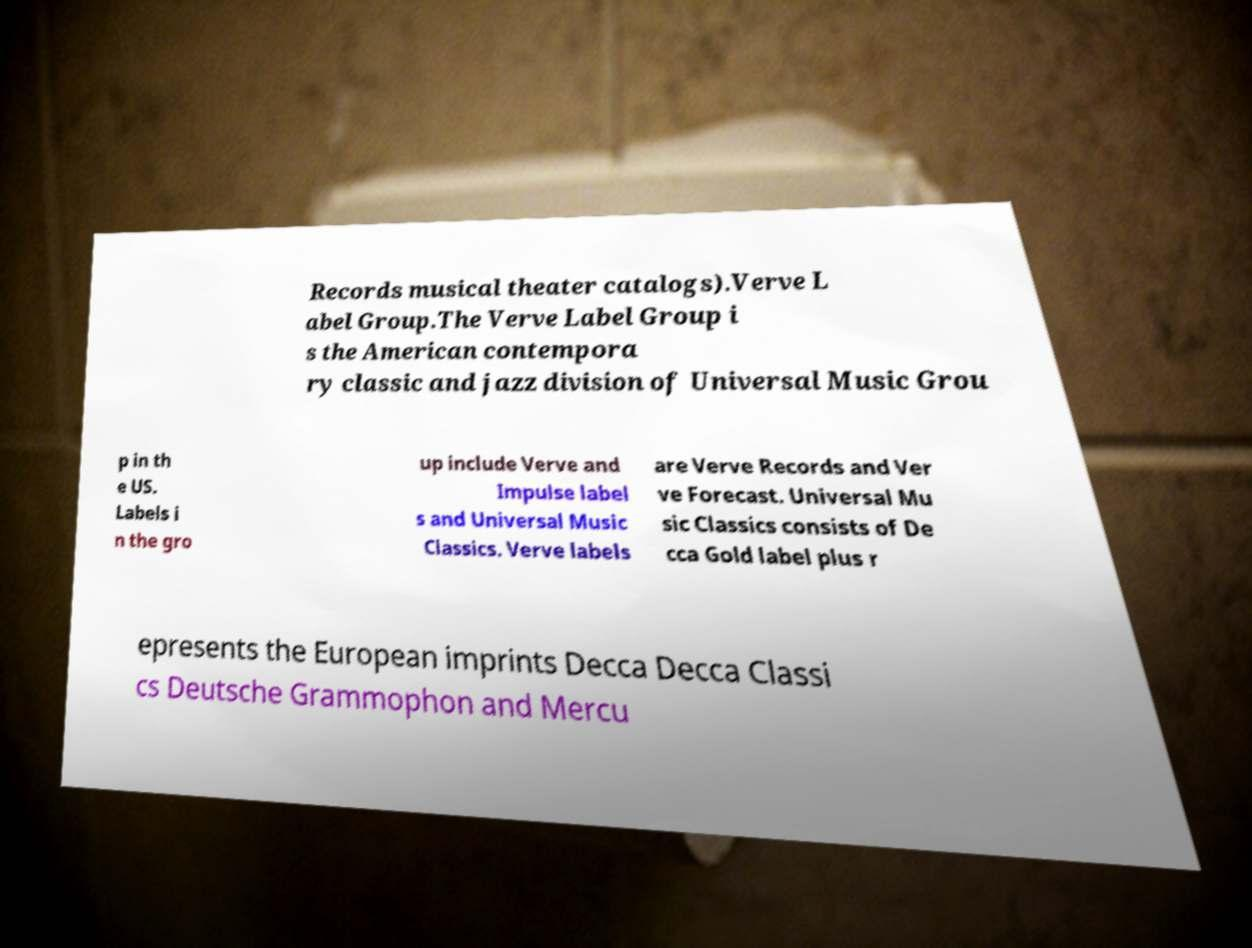There's text embedded in this image that I need extracted. Can you transcribe it verbatim? Records musical theater catalogs).Verve L abel Group.The Verve Label Group i s the American contempora ry classic and jazz division of Universal Music Grou p in th e US. Labels i n the gro up include Verve and Impulse label s and Universal Music Classics. Verve labels are Verve Records and Ver ve Forecast. Universal Mu sic Classics consists of De cca Gold label plus r epresents the European imprints Decca Decca Classi cs Deutsche Grammophon and Mercu 